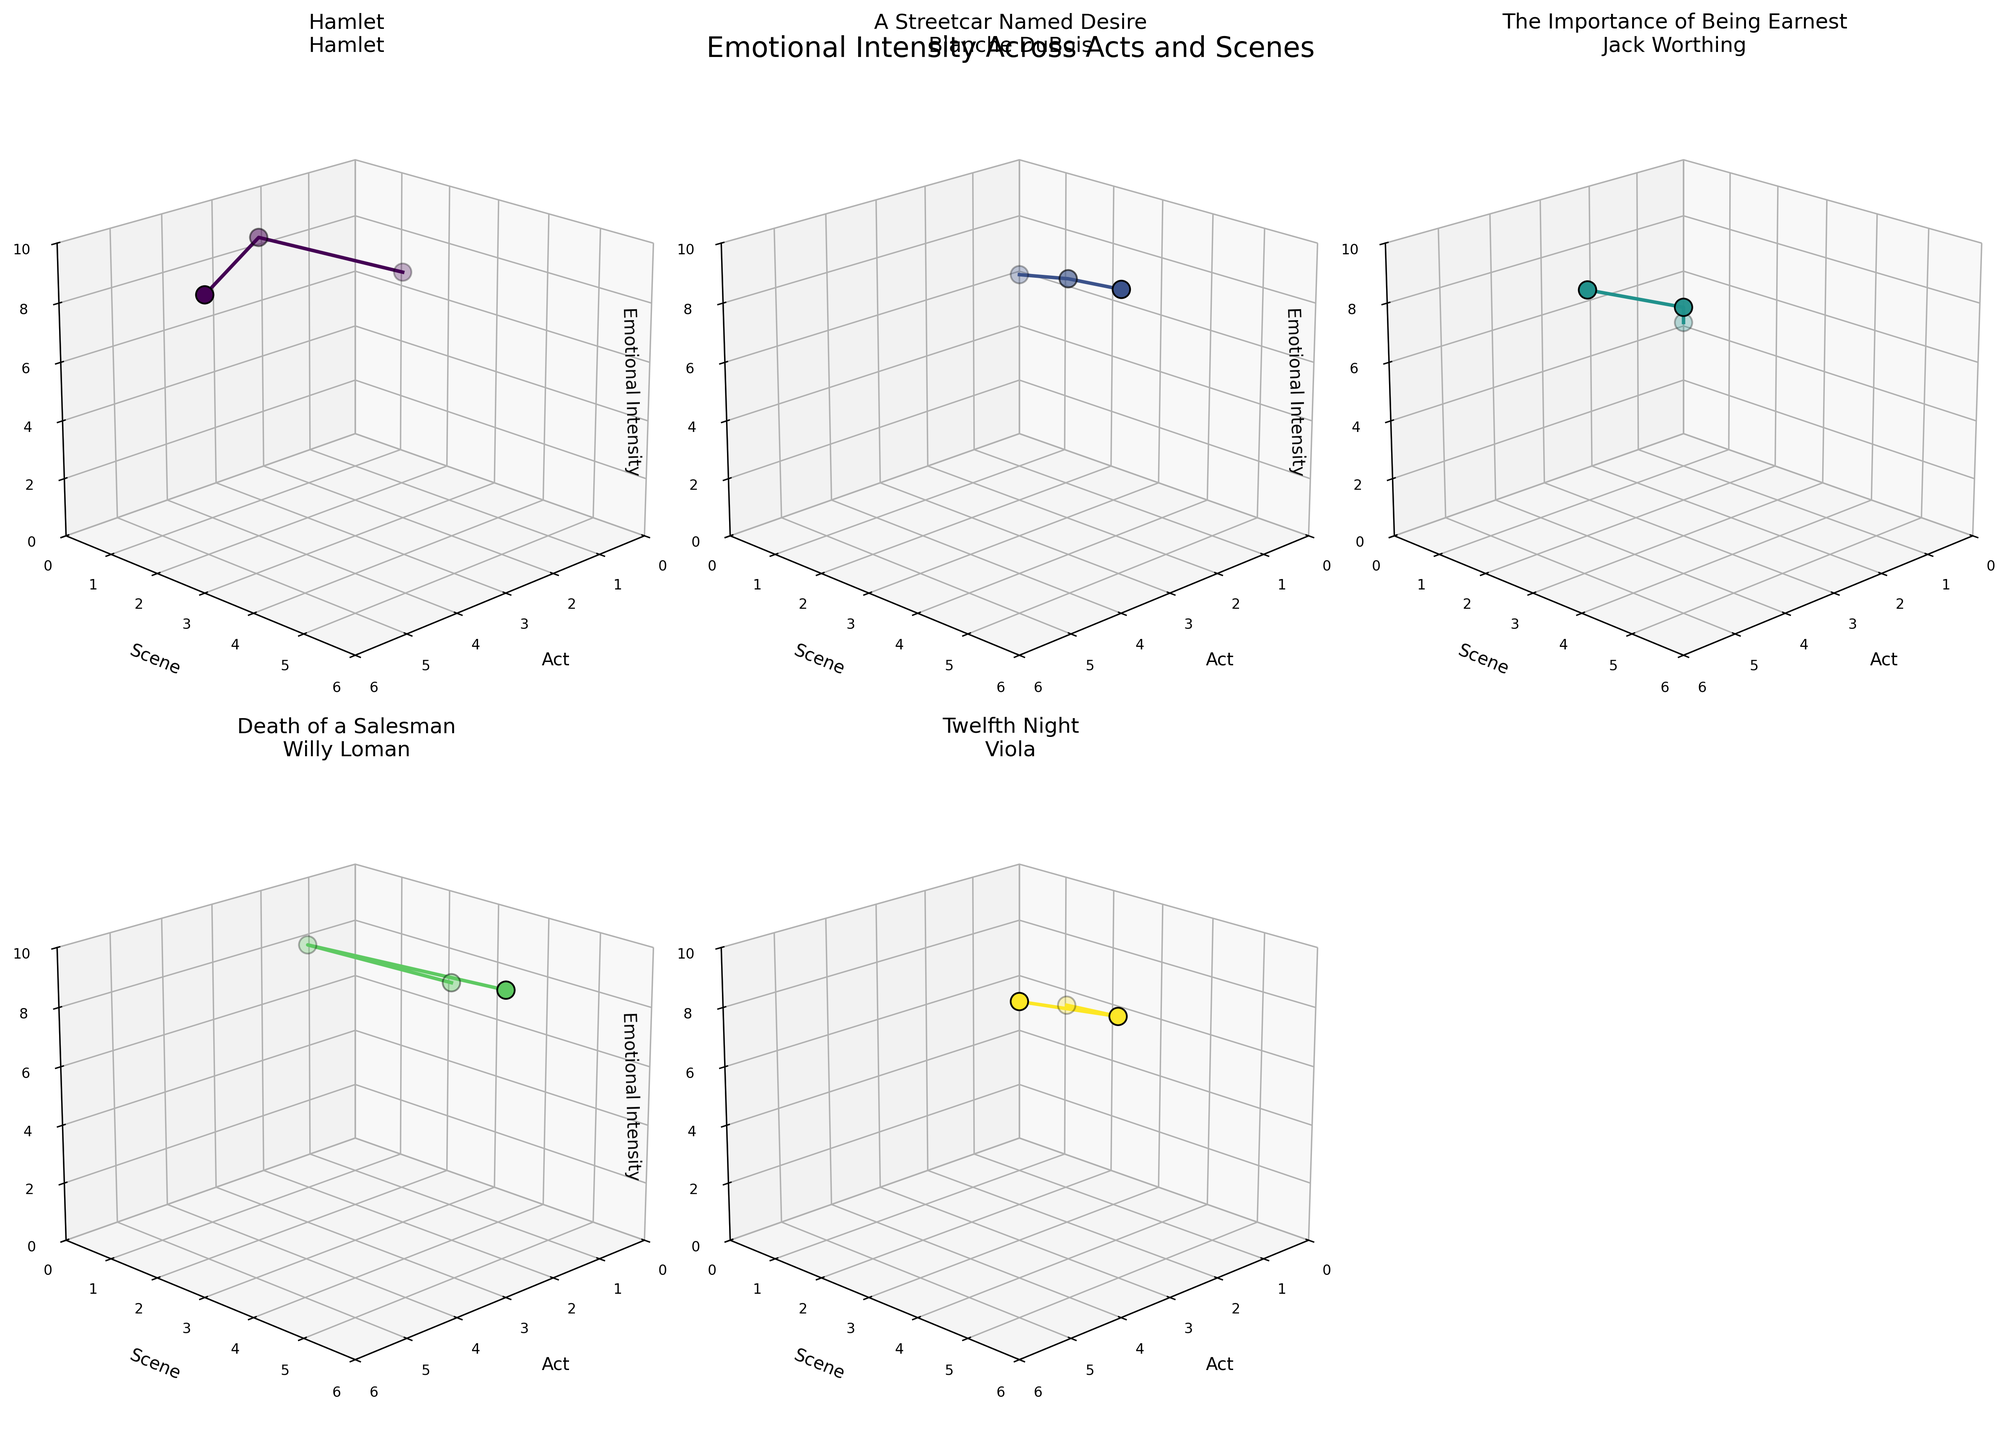What's the title of the entire figure? The title of the entire figure is located at the top and provides an overview of the subject matter of the plots.
Answer: Emotional Intensity Across Acts and Scenes What are the axis labels for each subplot? Each subplot has three axes, which are labeled respectively. The X-axis represents "Act," the Y-axis represents "Scene," and the Z-axis represents "Emotional Intensity".
Answer: Act, Scene, Emotional Intensity Which production has the highest emotional intensity across all acts and scenes? To find which production has the highest emotional intensity, compare the maximum Z-axis value (Emotional Intensity) in each subplot. Blanche DuBois in "A Streetcar Named Desire" has a highest point at 9.5 in Act 3, Scene 5.
Answer: A Streetcar Named Desire How does the emotional intensity of Hamlet change between Act 1, Scene 2 and Act 3, Scene 1? Compare the emotional intensity values of Hamlet at the specified acts and scenes. For Act 1, Scene 2 it’s 7.5, and for Act 3, Scene 1 it's 9.2. The change is 9.2 - 7.5.
Answer: Increase by 1.7 Which character has the steepest increase in emotional intensity between two consecutive scenes within the same act? To determine this, find the character with the largest positive difference between emotional intensities for two consecutive scenes within the same act. Willy Loman in "Death of a Salesman" shows a jump from 7.8 in Act 1, Scene 3 to 8.6 in Act 2, Scene 1.
Answer: Willy Loman What's the average emotional intensity for Jack Worthing in "The Importance of Being Earnest" over all acts? Calculate the average of the emotional intensities across all three acts for Jack Worthing: (5.2 + 6.8 + 7.4) / 3.
Answer: 6.47 How does the emotional intensity of Viola in Twelfth Night compare in Act 1, Scene 2 and Act 3, Scene 3? Identify and compare emotional intensity values at Act 1, Scene 2 and Act 3, Scene 3 for Viola. For Act 1, Scene 2 it's 6.5, and for Act 3, Scene 3 it's 8.2.
Answer: Increase by 1.7 Which character has the most fluctuating emotional intensity changes across different acts and scenes? To determine this, examine the variation in Z-axis values for each character. Blanche DuBois in "A Streetcar Named Desire" shows significant variation with values 6.9, 8.3, and 9.5.
Answer: Blanche DuBois In which act and scene does Hamlet's emotional intensity peak? Identify the highest Z-axis value in Hamlet's subplot and note the corresponding act and scene. The peak is at Act 3, Scene 1 with an intensity of 9.2.
Answer: Act 3, Scene 1 